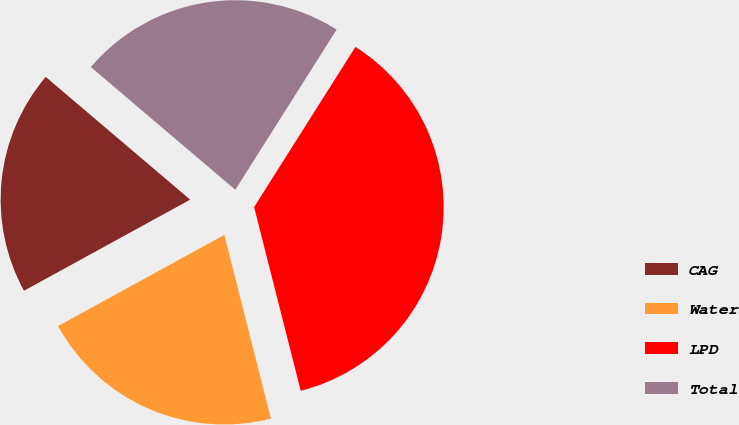<chart> <loc_0><loc_0><loc_500><loc_500><pie_chart><fcel>CAG<fcel>Water<fcel>LPD<fcel>Total<nl><fcel>19.19%<fcel>20.98%<fcel>37.07%<fcel>22.77%<nl></chart> 